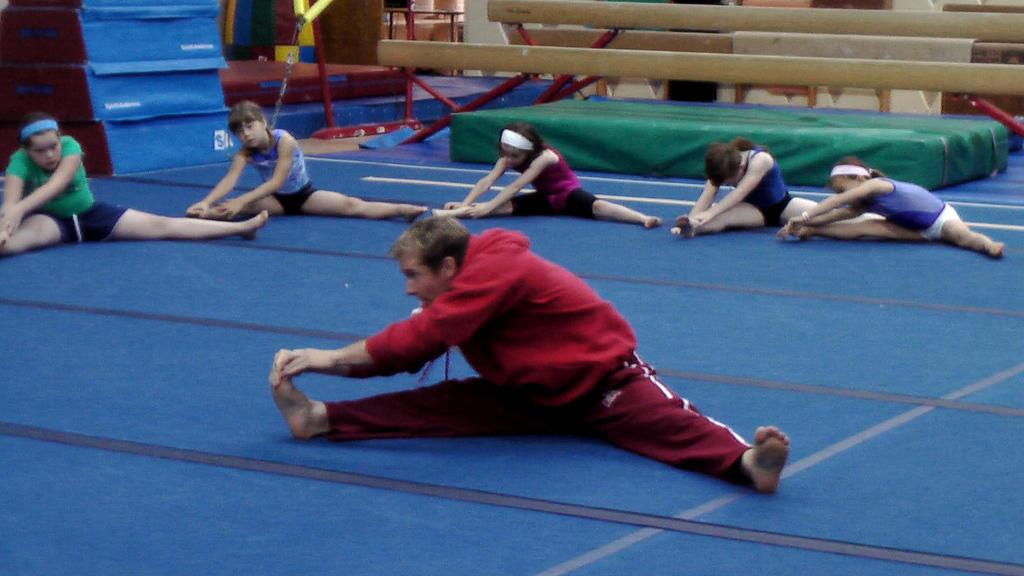What are the people in the image doing? The people in the image are doing exercises. What is the surface on which the exercises are being performed? There is a floor visible in the image. What can be seen in the background of the image? There are wooden sticks and boxes in the background of the image. How many books are stacked on the ant in the image? There are no books or ants present in the image. 